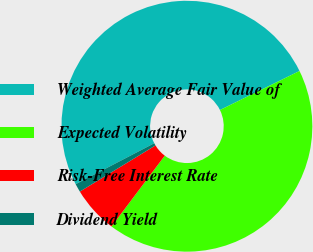<chart> <loc_0><loc_0><loc_500><loc_500><pie_chart><fcel>Weighted Average Fair Value of<fcel>Expected Volatility<fcel>Risk-Free Interest Rate<fcel>Dividend Yield<nl><fcel>50.39%<fcel>42.52%<fcel>6.01%<fcel>1.08%<nl></chart> 